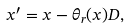Convert formula to latex. <formula><loc_0><loc_0><loc_500><loc_500>x ^ { \prime } = x - \theta _ { r } ( x ) D ,</formula> 